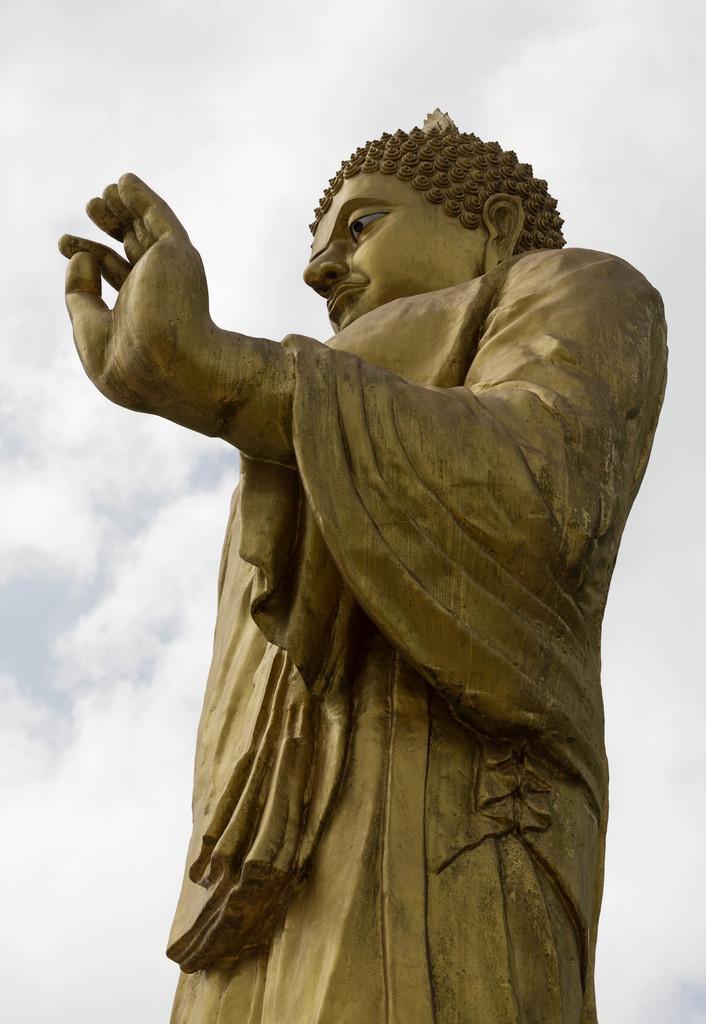Can you describe this image briefly? In this picture I can see a statue of Buddha, and in the background there is sky. 